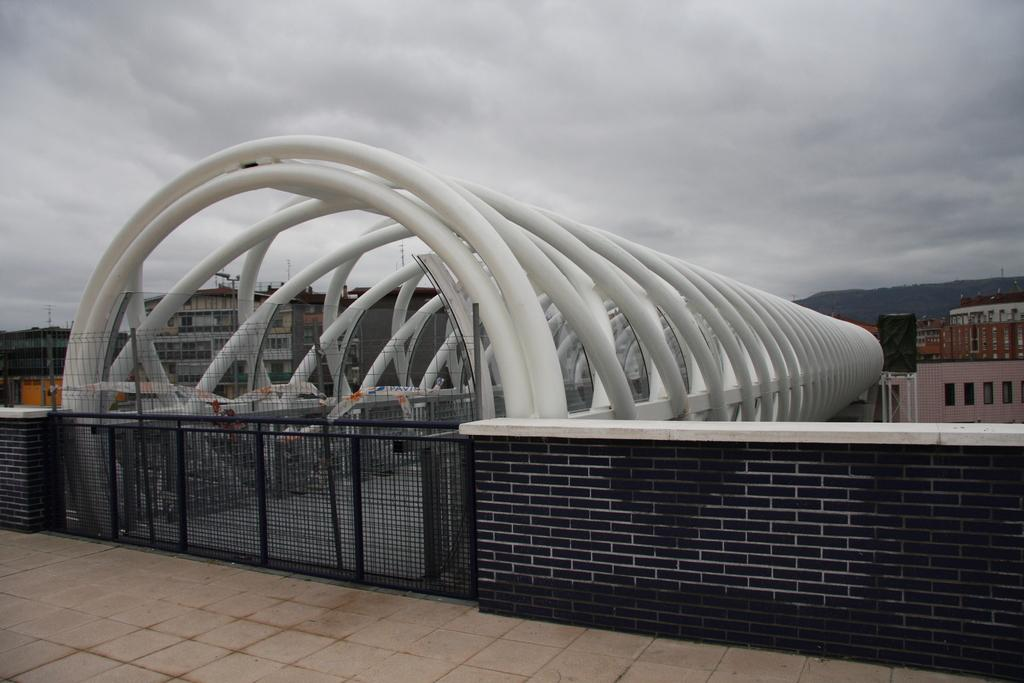What type of structure can be seen in the image? There is a fence in the image. What other objects are present in the image? There are poles in the image. What can be seen in the background of the image? There are buildings, a mountain, and the sky visible in the background of the image. Can you describe the unspecified objects in the background? Unfortunately, the provided facts do not specify the nature of the unspecified objects in the background. Where is the giraffe located in the image? There is no giraffe present in the image. What type of needle can be seen in the image? There is no needle present in the image. 